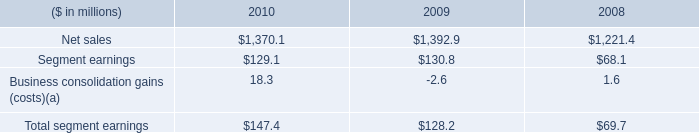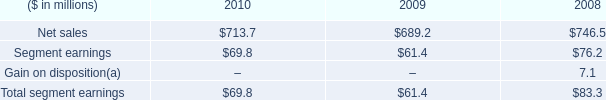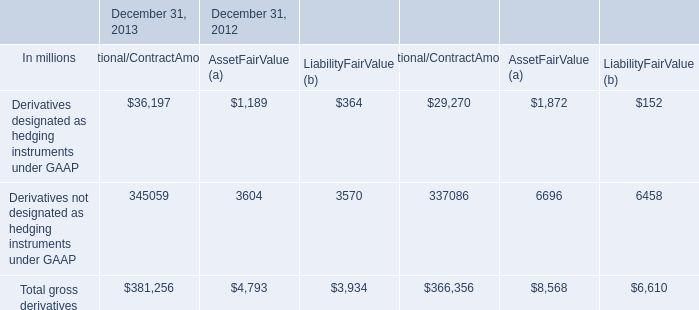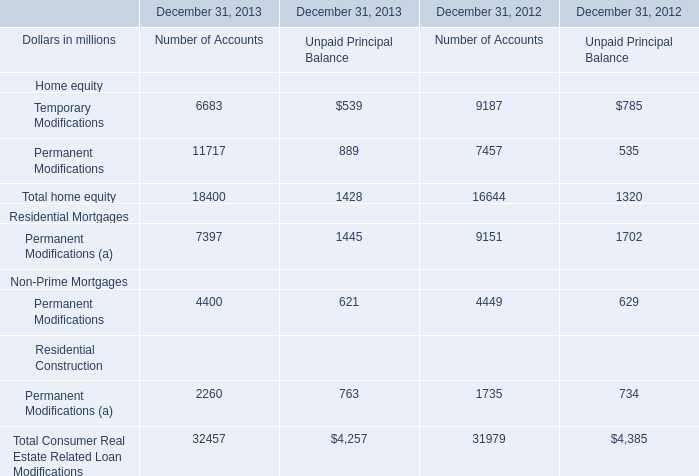What is the average amount of Permanent Modifications of December 31, 2012 Number of Accounts, and Net sales of 2010 ? 
Computations: ((7457.0 + 1370.1) / 2)
Answer: 4413.55. 